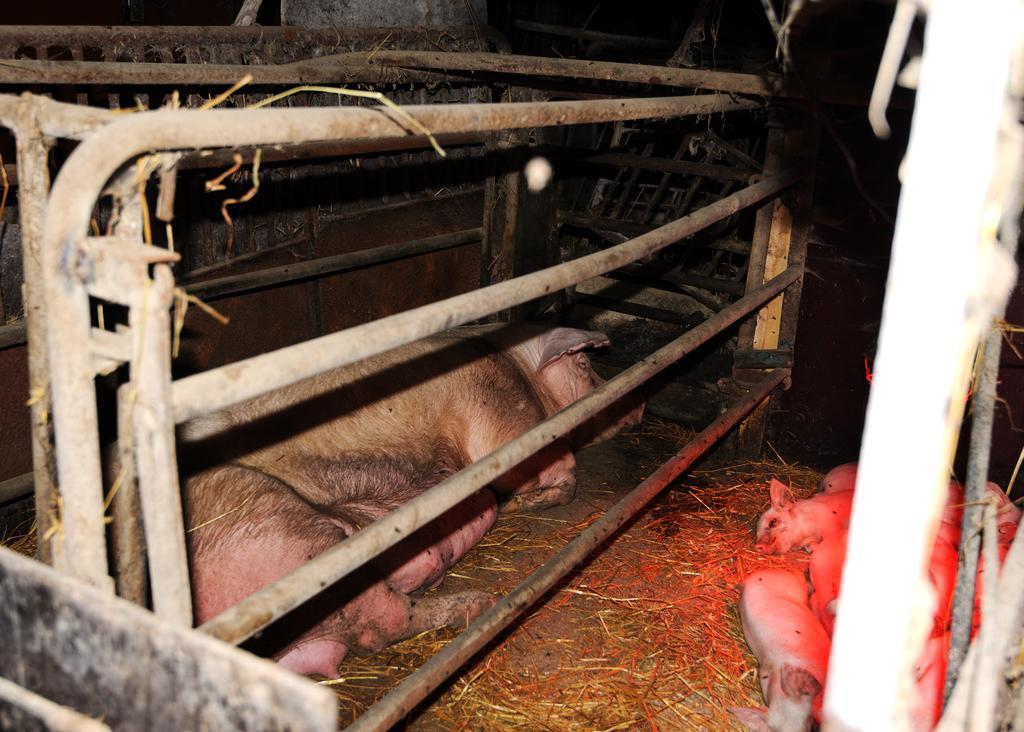In one or two sentences, can you explain what this image depicts? In this image there are animals on the ground and there is a rod stand and in the background there are scraps. 